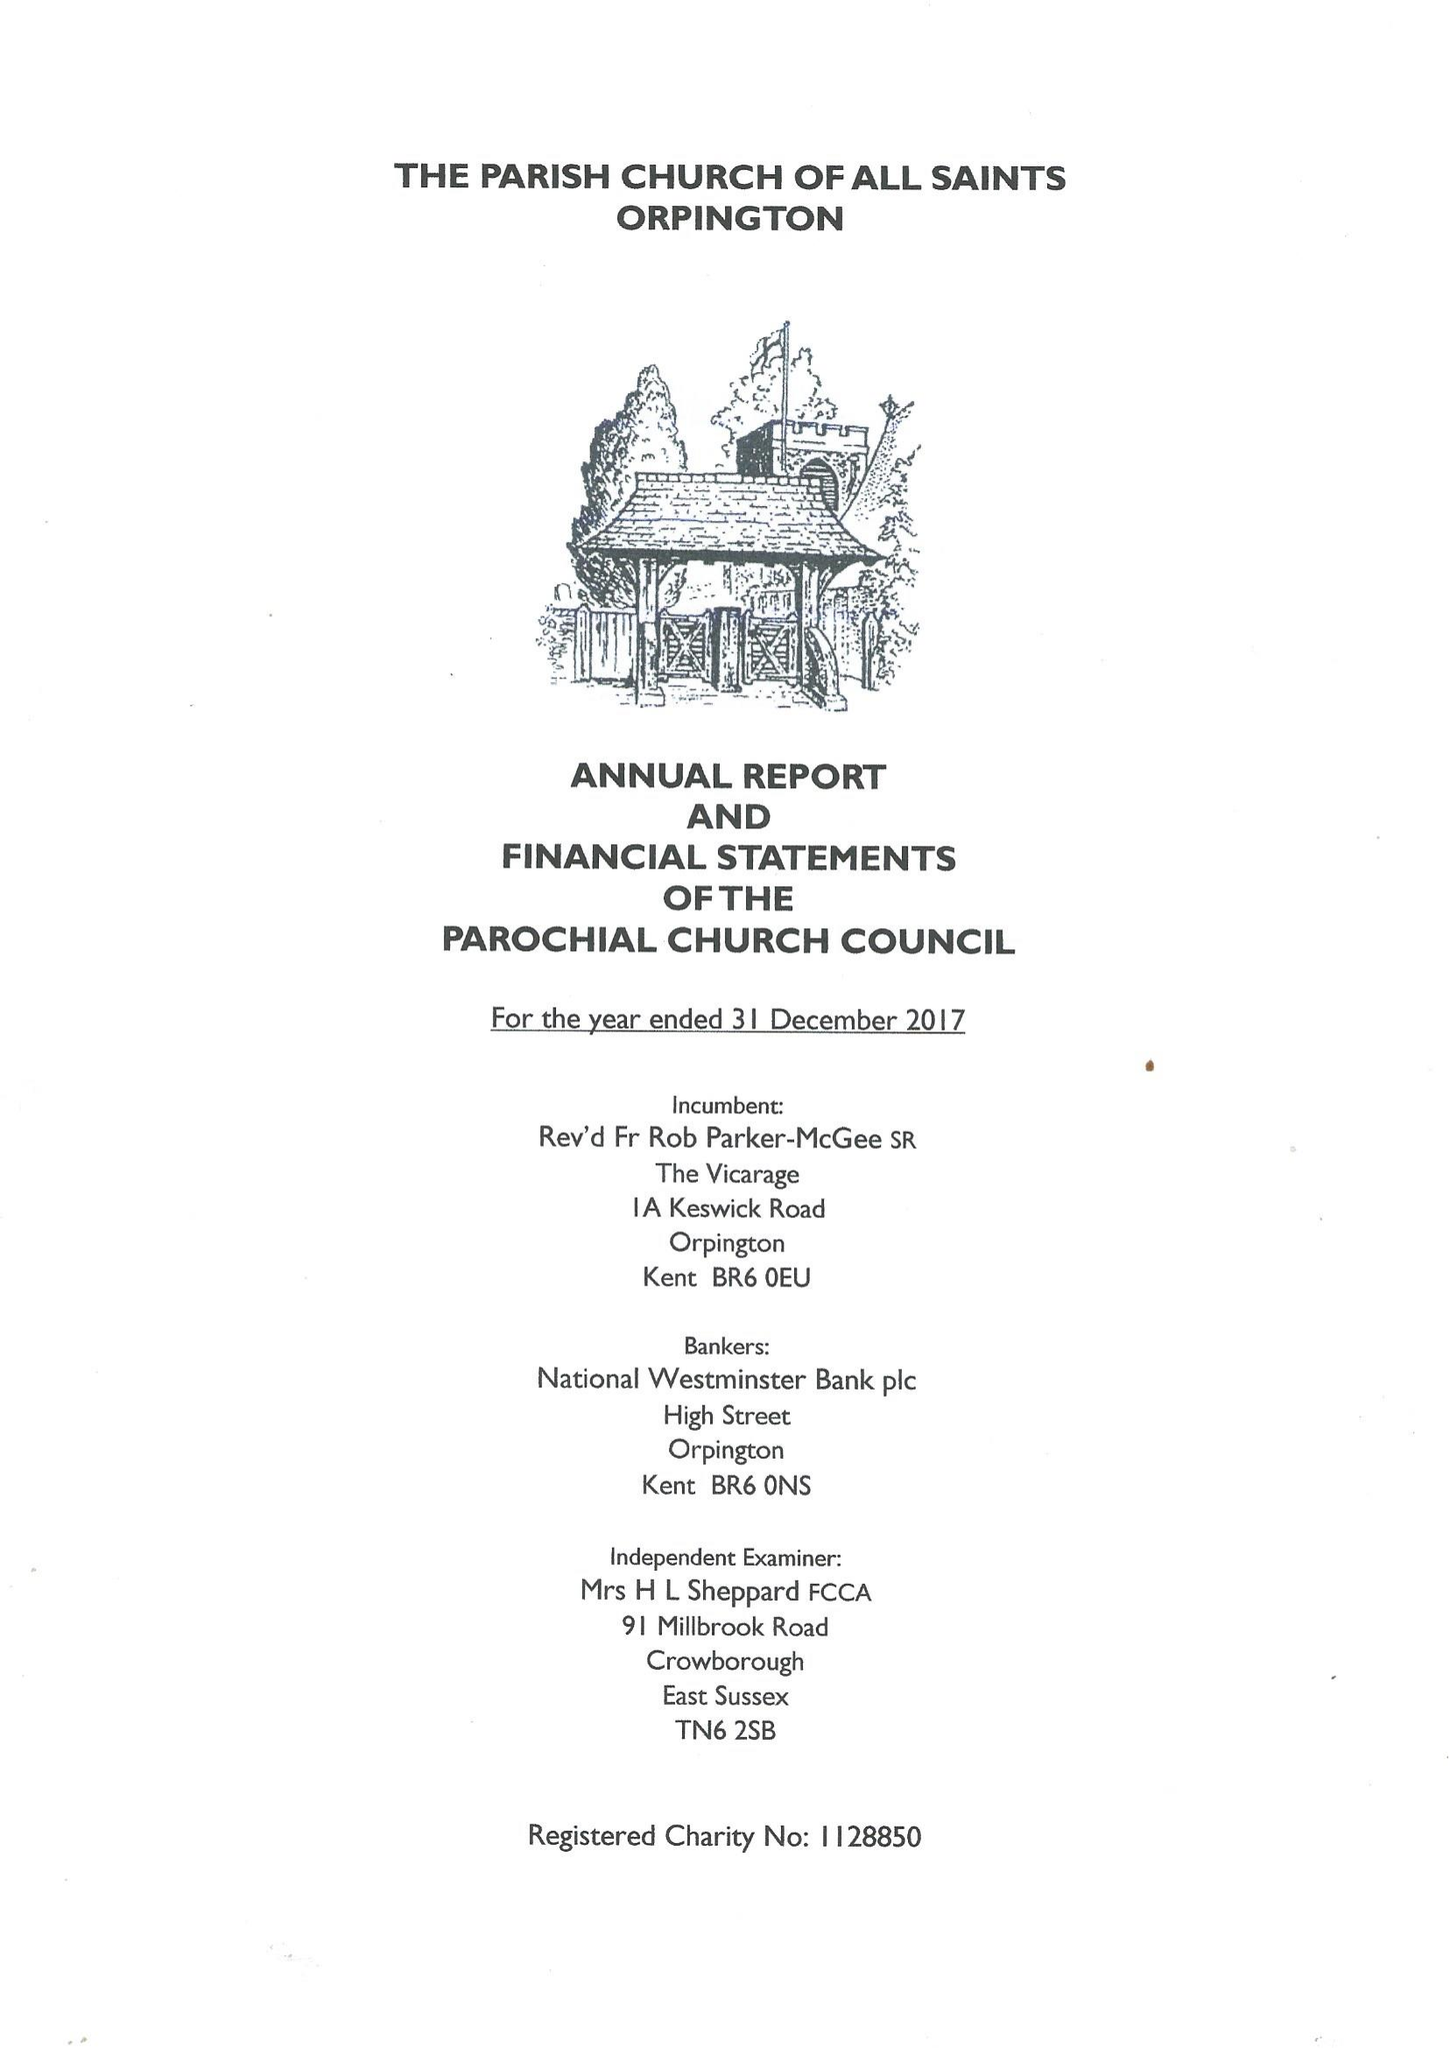What is the value for the spending_annually_in_british_pounds?
Answer the question using a single word or phrase. 245914.00 